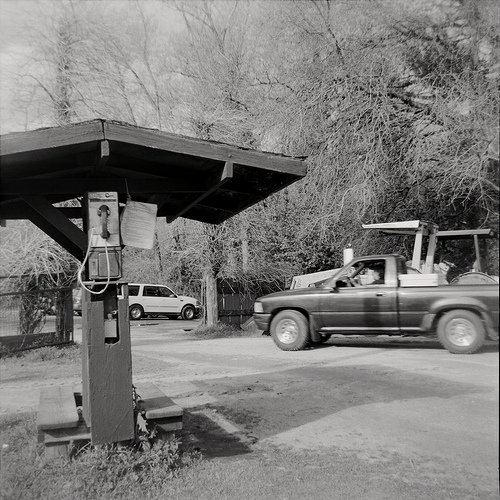Please provide the bounding box coordinate of the region this sentence describes: part of a wheel. The bounding box for part of a wheel is at coordinates [0.9, 0.62, 0.95, 0.68]. This captures a portion of the wheel, possibly from the truck in the image. 